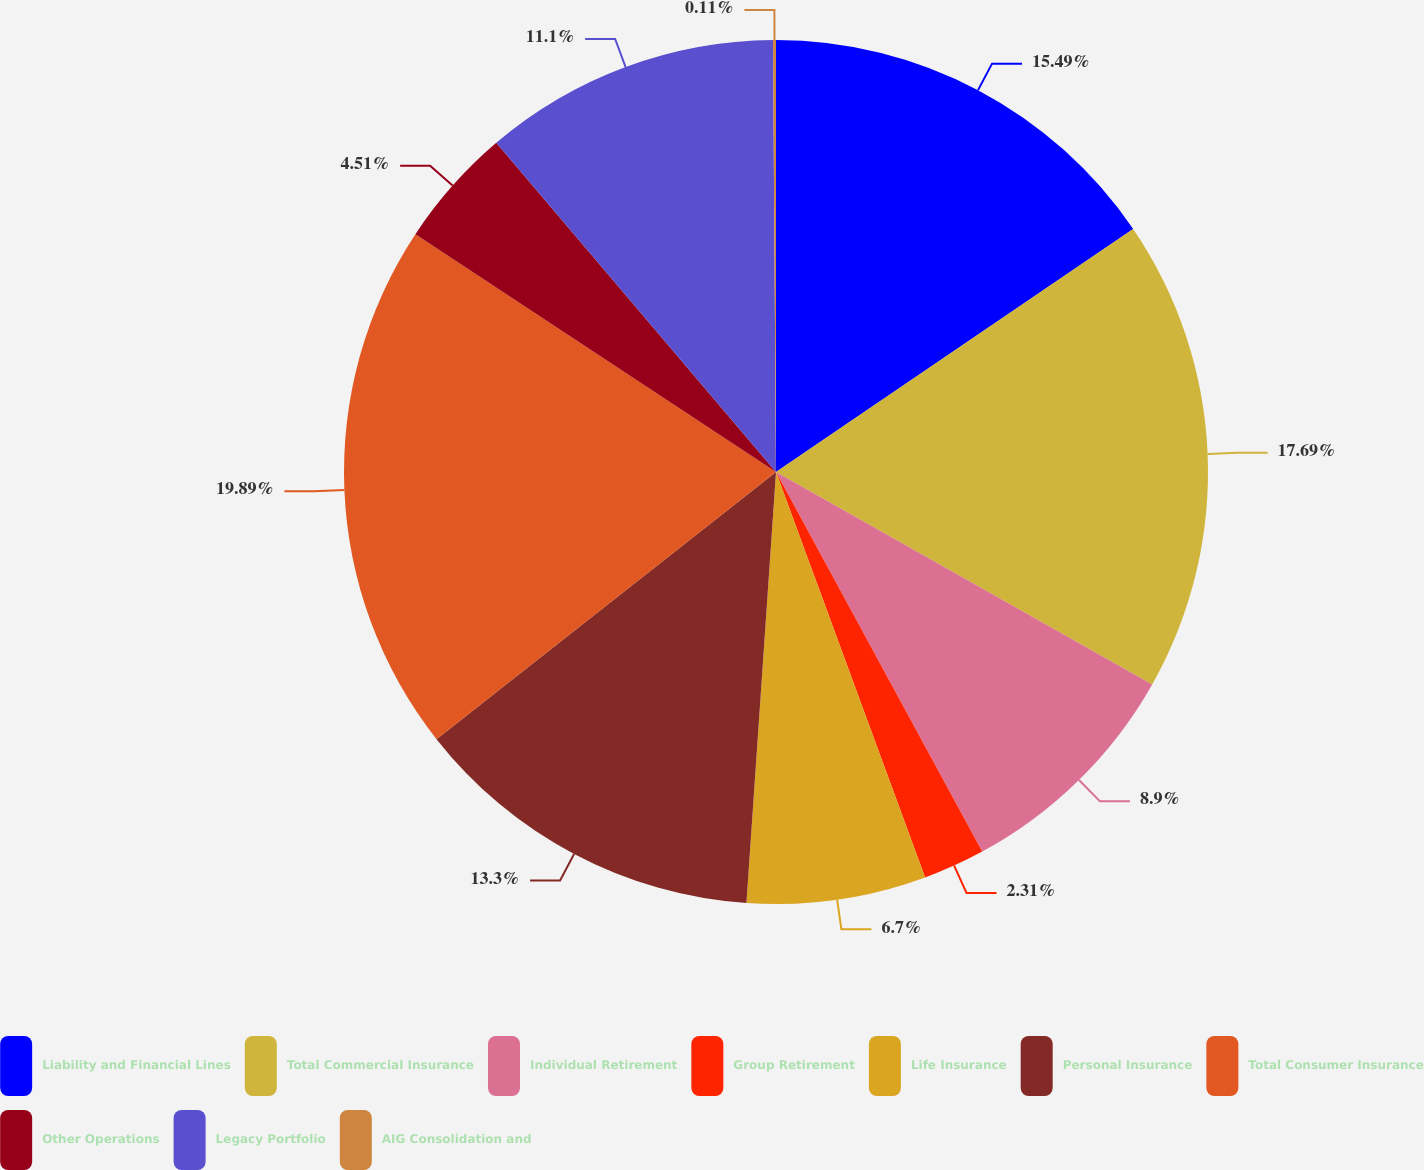Convert chart. <chart><loc_0><loc_0><loc_500><loc_500><pie_chart><fcel>Liability and Financial Lines<fcel>Total Commercial Insurance<fcel>Individual Retirement<fcel>Group Retirement<fcel>Life Insurance<fcel>Personal Insurance<fcel>Total Consumer Insurance<fcel>Other Operations<fcel>Legacy Portfolio<fcel>AIG Consolidation and<nl><fcel>15.49%<fcel>17.69%<fcel>8.9%<fcel>2.31%<fcel>6.7%<fcel>13.3%<fcel>19.89%<fcel>4.51%<fcel>11.1%<fcel>0.11%<nl></chart> 